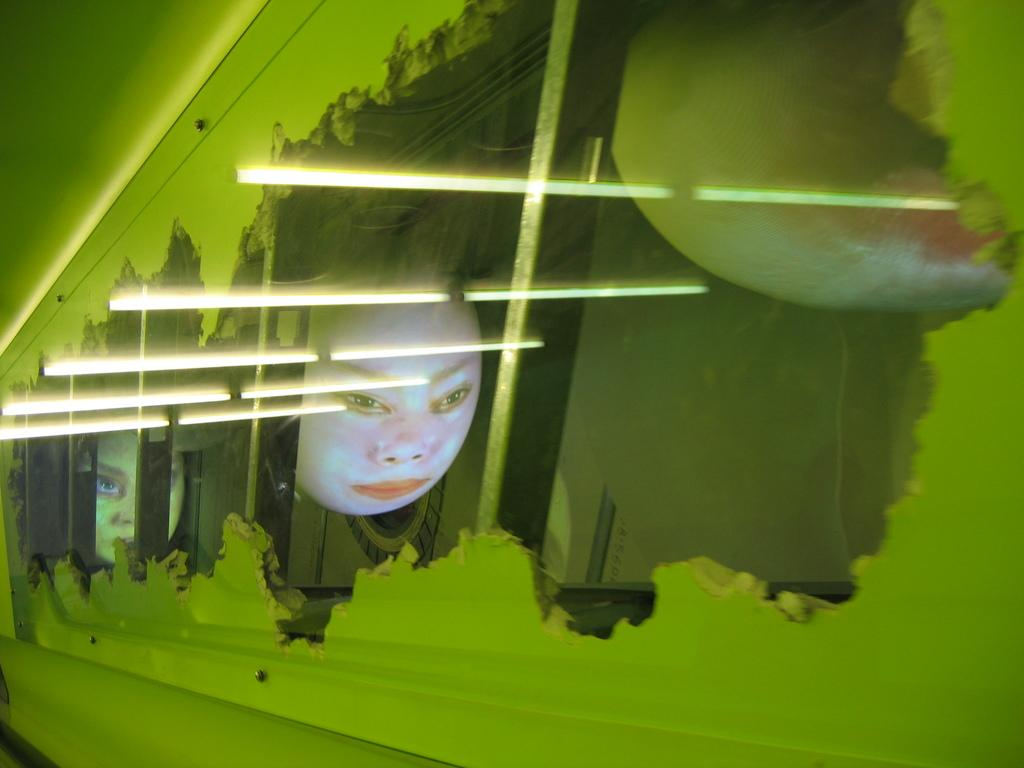What object is present in the picture with a green color frame? There is a glass in the picture with a green color frame. Can you describe the appearance of the glass? The glass has a green color frame. What can be seen in the reflection on the glass? There are reflections of two human faces and lights visible on the glass. What type of baseball play is happening in the reflection on the glass? There is no baseball play visible in the reflection on the glass; it only shows reflections of two human faces and lights. 